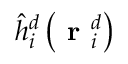Convert formula to latex. <formula><loc_0><loc_0><loc_500><loc_500>\hat { h } _ { i } ^ { d } \left ( r _ { i } ^ { d } \right )</formula> 